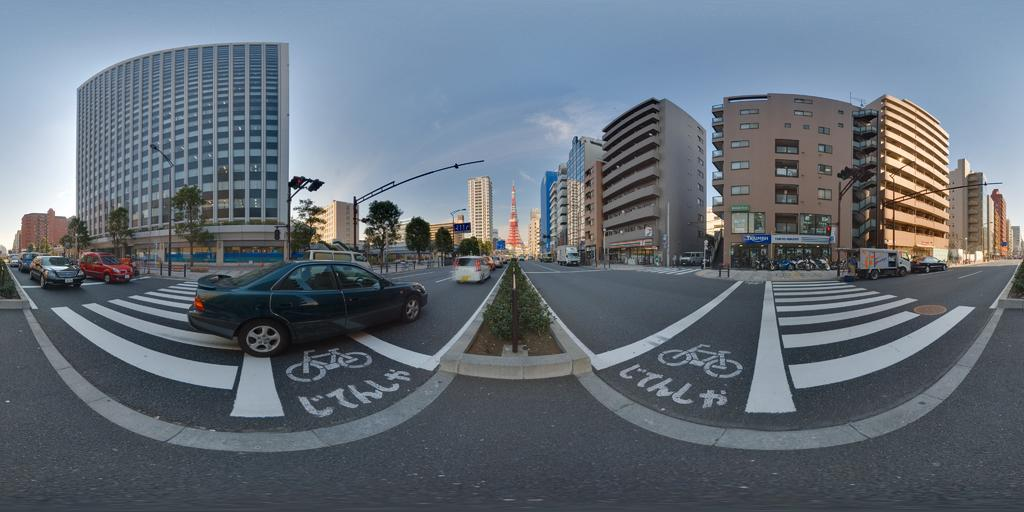What is happening on the road in the image? There are vehicles moving on the road in the image. What type of natural elements can be seen in the image? There are trees visible in the image. What type of man-made structures are present in the image? There are buildings in the image. What is the condition of the sky in the image? The sky is clear in the image. How many eyes can be seen on the bird in the image? There is no bird present in the image, so the number of eyes cannot be determined. 